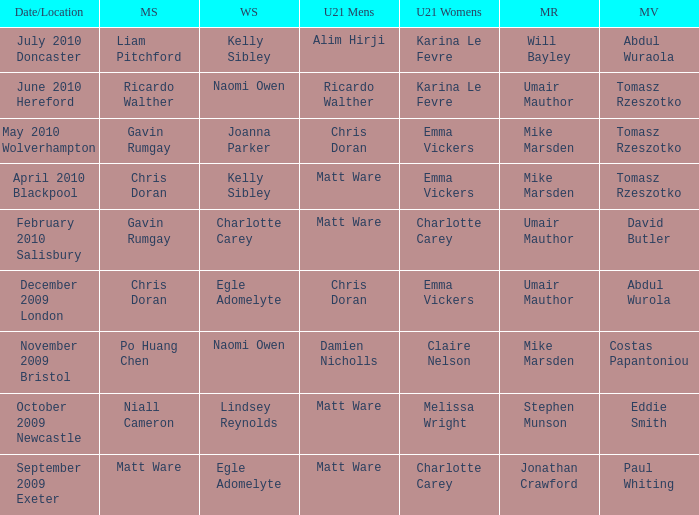Could you parse the entire table as a dict? {'header': ['Date/Location', 'MS', 'WS', 'U21 Mens', 'U21 Womens', 'MR', 'MV'], 'rows': [['July 2010 Doncaster', 'Liam Pitchford', 'Kelly Sibley', 'Alim Hirji', 'Karina Le Fevre', 'Will Bayley', 'Abdul Wuraola'], ['June 2010 Hereford', 'Ricardo Walther', 'Naomi Owen', 'Ricardo Walther', 'Karina Le Fevre', 'Umair Mauthor', 'Tomasz Rzeszotko'], ['May 2010 Wolverhampton', 'Gavin Rumgay', 'Joanna Parker', 'Chris Doran', 'Emma Vickers', 'Mike Marsden', 'Tomasz Rzeszotko'], ['April 2010 Blackpool', 'Chris Doran', 'Kelly Sibley', 'Matt Ware', 'Emma Vickers', 'Mike Marsden', 'Tomasz Rzeszotko'], ['February 2010 Salisbury', 'Gavin Rumgay', 'Charlotte Carey', 'Matt Ware', 'Charlotte Carey', 'Umair Mauthor', 'David Butler'], ['December 2009 London', 'Chris Doran', 'Egle Adomelyte', 'Chris Doran', 'Emma Vickers', 'Umair Mauthor', 'Abdul Wurola'], ['November 2009 Bristol', 'Po Huang Chen', 'Naomi Owen', 'Damien Nicholls', 'Claire Nelson', 'Mike Marsden', 'Costas Papantoniou'], ['October 2009 Newcastle', 'Niall Cameron', 'Lindsey Reynolds', 'Matt Ware', 'Melissa Wright', 'Stephen Munson', 'Eddie Smith'], ['September 2009 Exeter', 'Matt Ware', 'Egle Adomelyte', 'Matt Ware', 'Charlotte Carey', 'Jonathan Crawford', 'Paul Whiting']]} When Paul Whiting won the mixed veteran, who won the mixed restricted? Jonathan Crawford. 